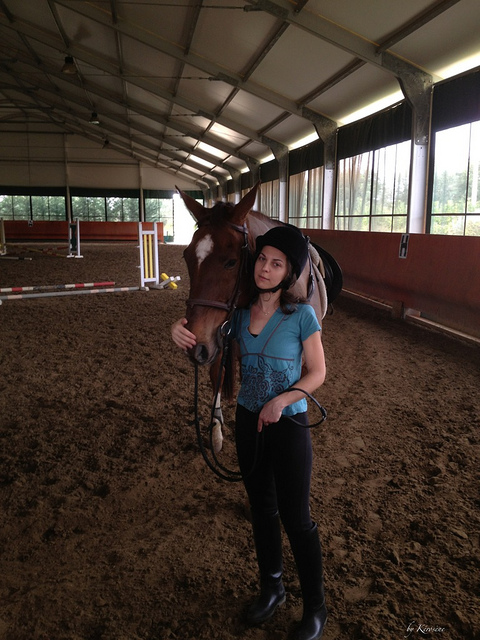<image>What city is the person in? It is ambiguous what city the person is in. What city is the person in? It is ambiguous what city the person is in. Possible cities are 'Rome', 'Dallas', 'Farm Village', 'Louisville', 'New York', 'Macomb IL', and 'Austin'. 